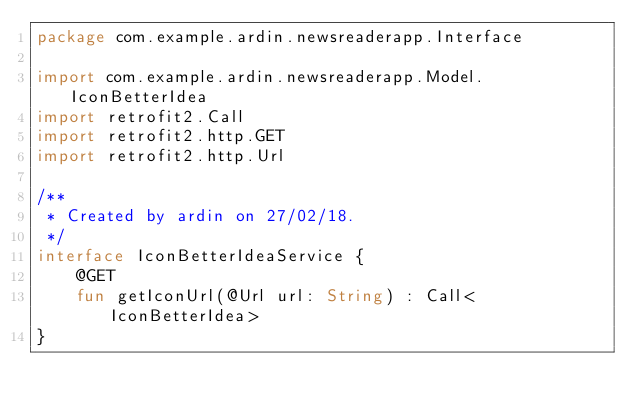<code> <loc_0><loc_0><loc_500><loc_500><_Kotlin_>package com.example.ardin.newsreaderapp.Interface

import com.example.ardin.newsreaderapp.Model.IconBetterIdea
import retrofit2.Call
import retrofit2.http.GET
import retrofit2.http.Url

/**
 * Created by ardin on 27/02/18.
 */
interface IconBetterIdeaService {
    @GET
    fun getIconUrl(@Url url: String) : Call<IconBetterIdea>
}</code> 